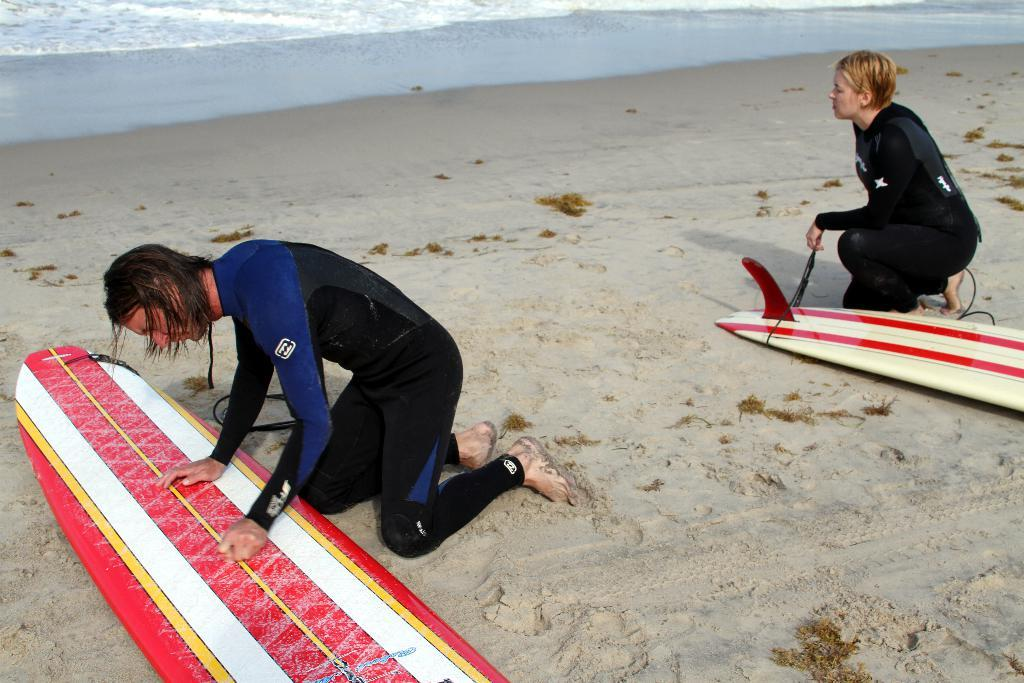How many people are in the image? There are two persons in the image. What is the surface they are standing on? The persons are on the sand. What objects are associated with the activity they might be engaged in? There are surfboards in the image. What can be seen in the distance behind them? There is water visible in the background of the image. What type of lettuce can be seen growing near the seashore in the image? There is no lettuce visible in the image, and the image does not depict a seashore. 